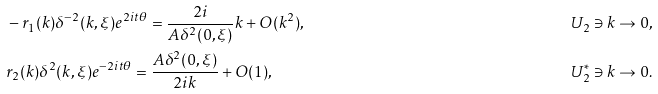Convert formula to latex. <formula><loc_0><loc_0><loc_500><loc_500>& - r _ { 1 } ( k ) \delta ^ { - 2 } ( k , \xi ) e ^ { 2 i t \theta } = \frac { 2 i } { A \delta ^ { 2 } ( 0 , \xi ) } k + O ( k ^ { 2 } ) , & U _ { 2 } \ni k \rightarrow 0 , \\ & r _ { 2 } ( k ) \delta ^ { 2 } ( k , \xi ) e ^ { - 2 i t \theta } = \frac { A \delta ^ { 2 } ( 0 , \xi ) } { 2 i k } + O ( 1 ) , & U ^ { * } _ { 2 } \ni k \rightarrow 0 .</formula> 